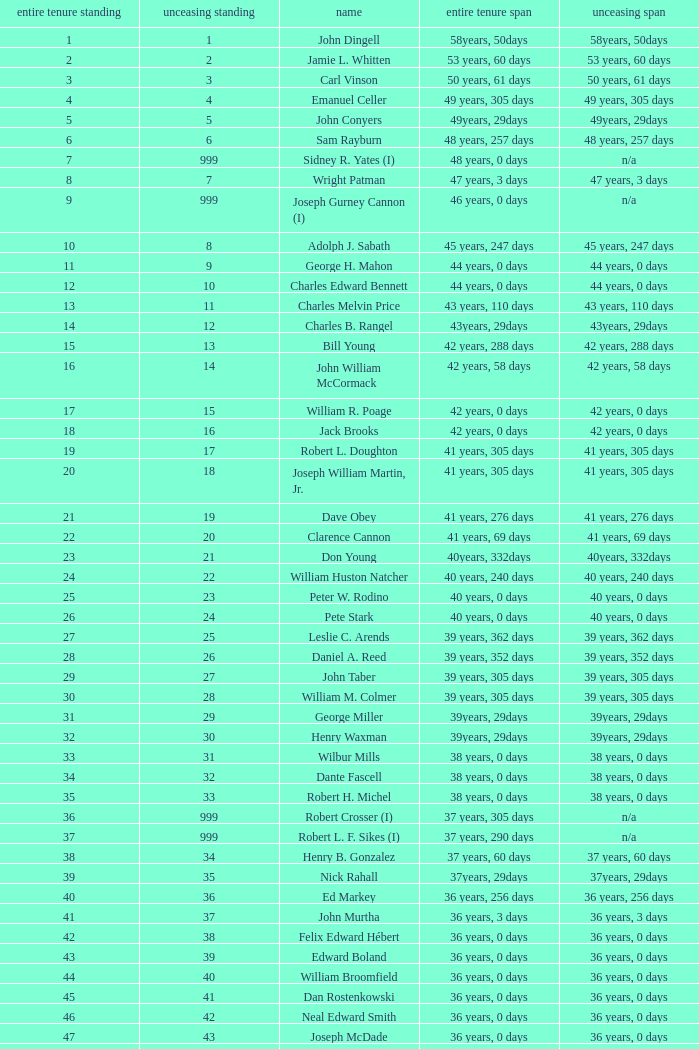Could you parse the entire table as a dict? {'header': ['entire tenure standing', 'unceasing standing', 'name', 'entire tenure span', 'unceasing span'], 'rows': [['1', '1', 'John Dingell', '58years, 50days', '58years, 50days'], ['2', '2', 'Jamie L. Whitten', '53 years, 60 days', '53 years, 60 days'], ['3', '3', 'Carl Vinson', '50 years, 61 days', '50 years, 61 days'], ['4', '4', 'Emanuel Celler', '49 years, 305 days', '49 years, 305 days'], ['5', '5', 'John Conyers', '49years, 29days', '49years, 29days'], ['6', '6', 'Sam Rayburn', '48 years, 257 days', '48 years, 257 days'], ['7', '999', 'Sidney R. Yates (I)', '48 years, 0 days', 'n/a'], ['8', '7', 'Wright Patman', '47 years, 3 days', '47 years, 3 days'], ['9', '999', 'Joseph Gurney Cannon (I)', '46 years, 0 days', 'n/a'], ['10', '8', 'Adolph J. Sabath', '45 years, 247 days', '45 years, 247 days'], ['11', '9', 'George H. Mahon', '44 years, 0 days', '44 years, 0 days'], ['12', '10', 'Charles Edward Bennett', '44 years, 0 days', '44 years, 0 days'], ['13', '11', 'Charles Melvin Price', '43 years, 110 days', '43 years, 110 days'], ['14', '12', 'Charles B. Rangel', '43years, 29days', '43years, 29days'], ['15', '13', 'Bill Young', '42 years, 288 days', '42 years, 288 days'], ['16', '14', 'John William McCormack', '42 years, 58 days', '42 years, 58 days'], ['17', '15', 'William R. Poage', '42 years, 0 days', '42 years, 0 days'], ['18', '16', 'Jack Brooks', '42 years, 0 days', '42 years, 0 days'], ['19', '17', 'Robert L. Doughton', '41 years, 305 days', '41 years, 305 days'], ['20', '18', 'Joseph William Martin, Jr.', '41 years, 305 days', '41 years, 305 days'], ['21', '19', 'Dave Obey', '41 years, 276 days', '41 years, 276 days'], ['22', '20', 'Clarence Cannon', '41 years, 69 days', '41 years, 69 days'], ['23', '21', 'Don Young', '40years, 332days', '40years, 332days'], ['24', '22', 'William Huston Natcher', '40 years, 240 days', '40 years, 240 days'], ['25', '23', 'Peter W. Rodino', '40 years, 0 days', '40 years, 0 days'], ['26', '24', 'Pete Stark', '40 years, 0 days', '40 years, 0 days'], ['27', '25', 'Leslie C. Arends', '39 years, 362 days', '39 years, 362 days'], ['28', '26', 'Daniel A. Reed', '39 years, 352 days', '39 years, 352 days'], ['29', '27', 'John Taber', '39 years, 305 days', '39 years, 305 days'], ['30', '28', 'William M. Colmer', '39 years, 305 days', '39 years, 305 days'], ['31', '29', 'George Miller', '39years, 29days', '39years, 29days'], ['32', '30', 'Henry Waxman', '39years, 29days', '39years, 29days'], ['33', '31', 'Wilbur Mills', '38 years, 0 days', '38 years, 0 days'], ['34', '32', 'Dante Fascell', '38 years, 0 days', '38 years, 0 days'], ['35', '33', 'Robert H. Michel', '38 years, 0 days', '38 years, 0 days'], ['36', '999', 'Robert Crosser (I)', '37 years, 305 days', 'n/a'], ['37', '999', 'Robert L. F. Sikes (I)', '37 years, 290 days', 'n/a'], ['38', '34', 'Henry B. Gonzalez', '37 years, 60 days', '37 years, 60 days'], ['39', '35', 'Nick Rahall', '37years, 29days', '37years, 29days'], ['40', '36', 'Ed Markey', '36 years, 256 days', '36 years, 256 days'], ['41', '37', 'John Murtha', '36 years, 3 days', '36 years, 3 days'], ['42', '38', 'Felix Edward Hébert', '36 years, 0 days', '36 years, 0 days'], ['43', '39', 'Edward Boland', '36 years, 0 days', '36 years, 0 days'], ['44', '40', 'William Broomfield', '36 years, 0 days', '36 years, 0 days'], ['45', '41', 'Dan Rostenkowski', '36 years, 0 days', '36 years, 0 days'], ['46', '42', 'Neal Edward Smith', '36 years, 0 days', '36 years, 0 days'], ['47', '43', 'Joseph McDade', '36 years, 0 days', '36 years, 0 days'], ['48', '44', 'Ralph Regula', '36 years, 0 days', '36 years, 0 days'], ['49', '45', 'James Oberstar', '36 years, 0 days', '36 years, 0 days'], ['50', '46', 'Norman D. Dicks', '36 years, 0 days', '36 years, 0 days'], ['51', '47', 'Dale Kildee', '36 years, 0 days', '36 years, 0 days'], ['52', '999', 'Henry A. Cooper (I)', '36 years, 0 days', 'n/a']]} How many uninterrupted ranks does john dingell have? 1.0. 